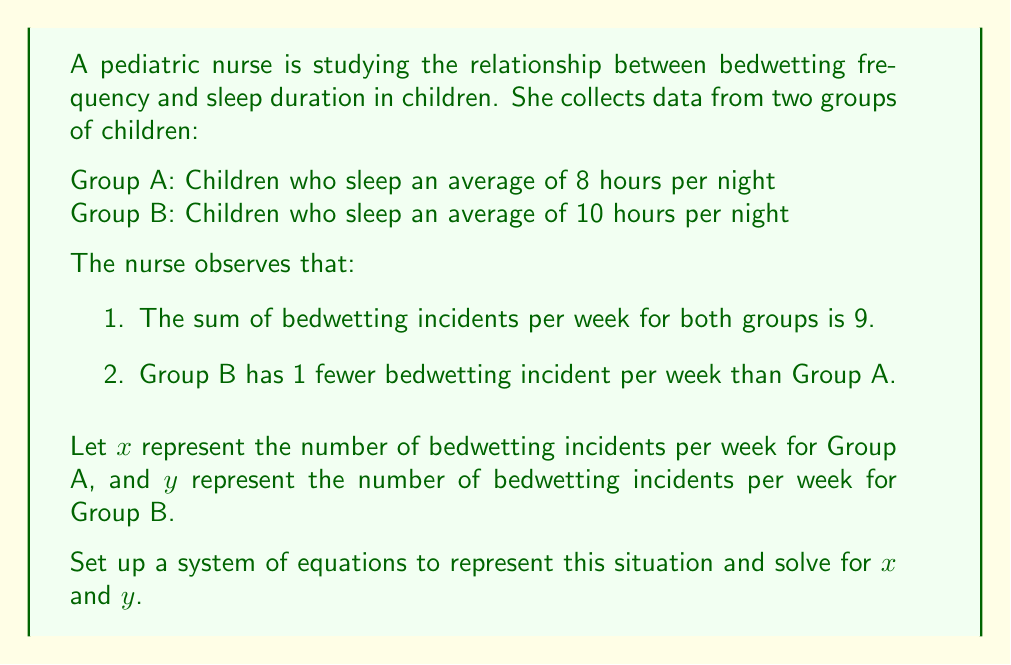What is the answer to this math problem? Let's approach this step-by-step:

1. Set up the system of equations:

   From the given information, we can create two equations:
   
   Equation 1: The sum of bedwetting incidents for both groups is 9
   $$x + y = 9$$
   
   Equation 2: Group B has 1 fewer bedwetting incident than Group A
   $$y = x - 1$$

2. Solve the system using substitution method:

   Substitute the expression for $y$ from Equation 2 into Equation 1:
   $$x + (x - 1) = 9$$

3. Solve for $x$:

   $$2x - 1 = 9$$
   $$2x = 10$$
   $$x = 5$$

4. Find $y$ by substituting $x = 5$ into Equation 2:

   $$y = 5 - 1 = 4$$

5. Verify the solution:

   Check if $x + y = 9$:
   $$5 + 4 = 9$$ (This is true)

   Check if $y = x - 1$:
   $$4 = 5 - 1$$ (This is also true)

Therefore, the solution satisfies both equations in the system.
Answer: Group A (8 hours of sleep): $x = 5$ bedwetting incidents per week
Group B (10 hours of sleep): $y = 4$ bedwetting incidents per week 